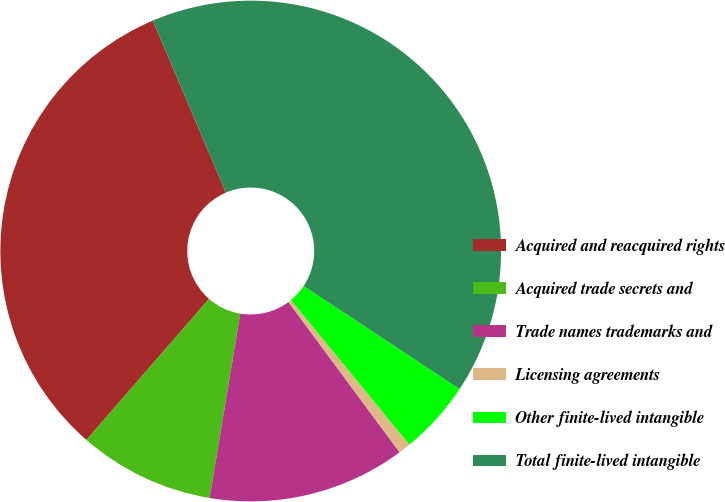Convert chart. <chart><loc_0><loc_0><loc_500><loc_500><pie_chart><fcel>Acquired and reacquired rights<fcel>Acquired trade secrets and<fcel>Trade names trademarks and<fcel>Licensing agreements<fcel>Other finite-lived intangible<fcel>Total finite-lived intangible<nl><fcel>32.21%<fcel>8.77%<fcel>12.76%<fcel>0.79%<fcel>4.78%<fcel>40.69%<nl></chart> 